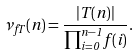Convert formula to latex. <formula><loc_0><loc_0><loc_500><loc_500>\nu _ { f T } ( n ) = \frac { | T ( n ) | } { \prod _ { i = 0 } ^ { n - 1 } f ( i ) } .</formula> 